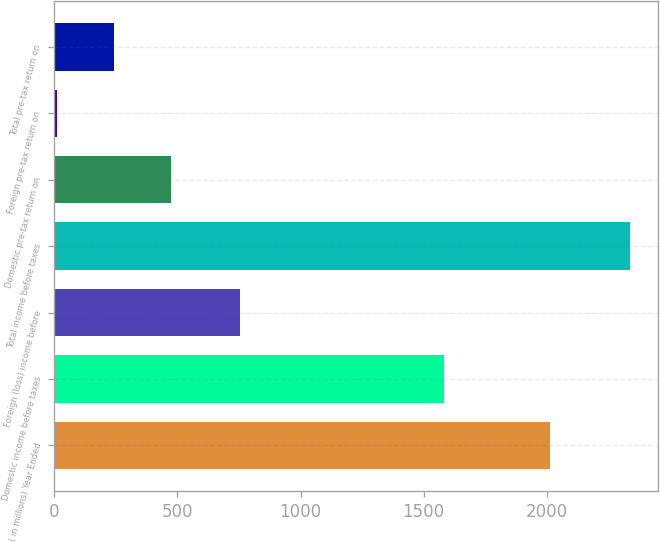Convert chart. <chart><loc_0><loc_0><loc_500><loc_500><bar_chart><fcel>( in millions) Year Ended<fcel>Domestic income before taxes<fcel>Foreign (loss) income before<fcel>Total income before taxes<fcel>Domestic pre-tax return on<fcel>Foreign pre-tax return on<fcel>Total pre-tax return on<nl><fcel>2015<fcel>1581.6<fcel>755.5<fcel>2337.1<fcel>475.34<fcel>9.9<fcel>242.62<nl></chart> 